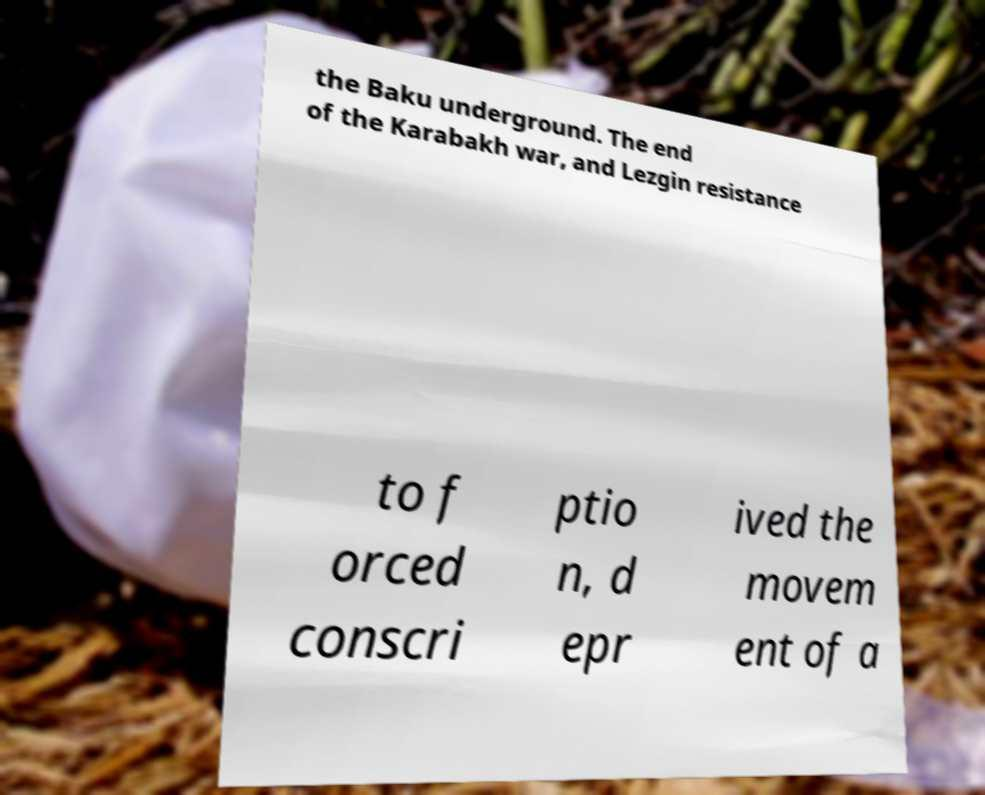Could you extract and type out the text from this image? the Baku underground. The end of the Karabakh war, and Lezgin resistance to f orced conscri ptio n, d epr ived the movem ent of a 